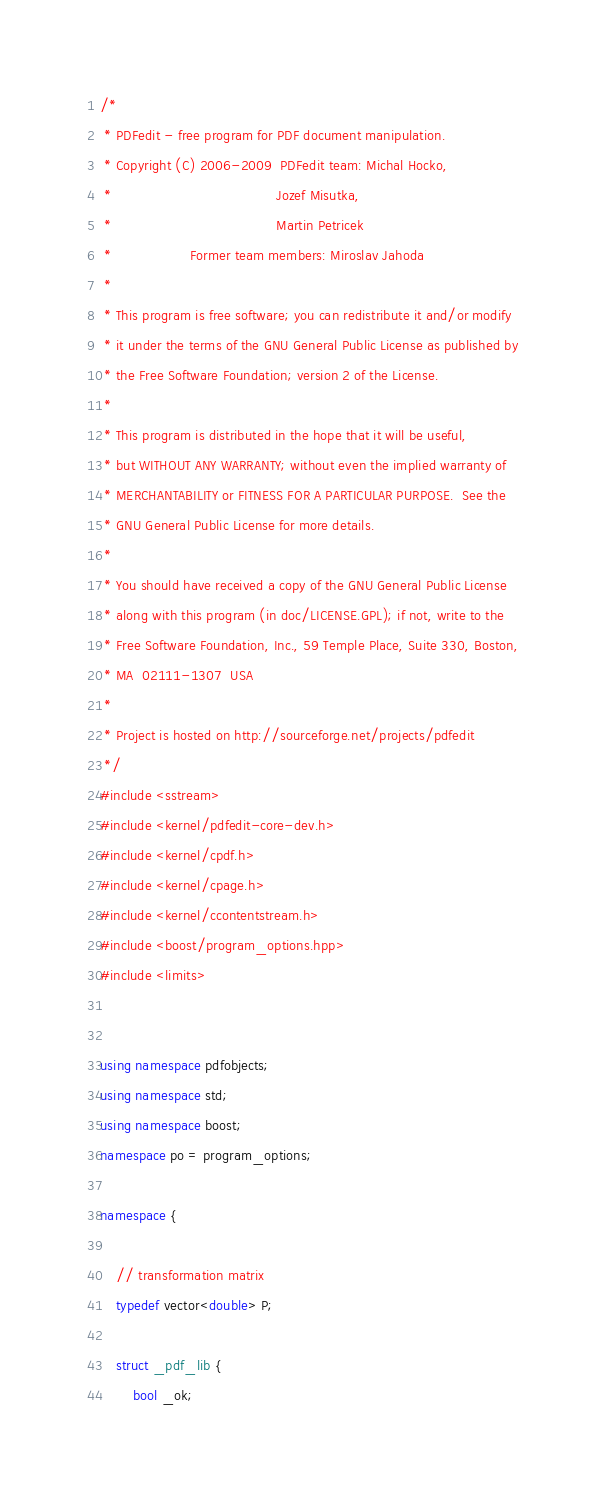<code> <loc_0><loc_0><loc_500><loc_500><_C++_>/*
 * PDFedit - free program for PDF document manipulation.
 * Copyright (C) 2006-2009  PDFedit team: Michal Hocko,
 *                                        Jozef Misutka,
 *                                        Martin Petricek
 *                   Former team members: Miroslav Jahoda
 *
 * This program is free software; you can redistribute it and/or modify
 * it under the terms of the GNU General Public License as published by
 * the Free Software Foundation; version 2 of the License.
 *
 * This program is distributed in the hope that it will be useful,
 * but WITHOUT ANY WARRANTY; without even the implied warranty of
 * MERCHANTABILITY or FITNESS FOR A PARTICULAR PURPOSE.  See the
 * GNU General Public License for more details.
 *
 * You should have received a copy of the GNU General Public License
 * along with this program (in doc/LICENSE.GPL); if not, write to the 
 * Free Software Foundation, Inc., 59 Temple Place, Suite 330, Boston, 
 * MA  02111-1307  USA
 *
 * Project is hosted on http://sourceforge.net/projects/pdfedit
 */
#include <sstream>
#include <kernel/pdfedit-core-dev.h>
#include <kernel/cpdf.h>
#include <kernel/cpage.h>
#include <kernel/ccontentstream.h>
#include <boost/program_options.hpp>
#include <limits>


using namespace pdfobjects;
using namespace std;
using namespace boost;
namespace po = program_options;

namespace {

	// transformation matrix
	typedef vector<double> P;

	struct _pdf_lib {
		bool _ok;</code> 